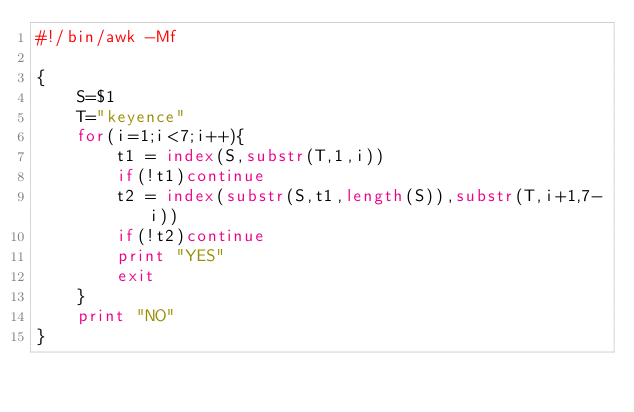Convert code to text. <code><loc_0><loc_0><loc_500><loc_500><_Awk_>#!/bin/awk -Mf

{
    S=$1
    T="keyence"
    for(i=1;i<7;i++){
        t1 = index(S,substr(T,1,i))
        if(!t1)continue
        t2 = index(substr(S,t1,length(S)),substr(T,i+1,7-i))
        if(!t2)continue
        print "YES"
        exit
    }
    print "NO"
}
</code> 